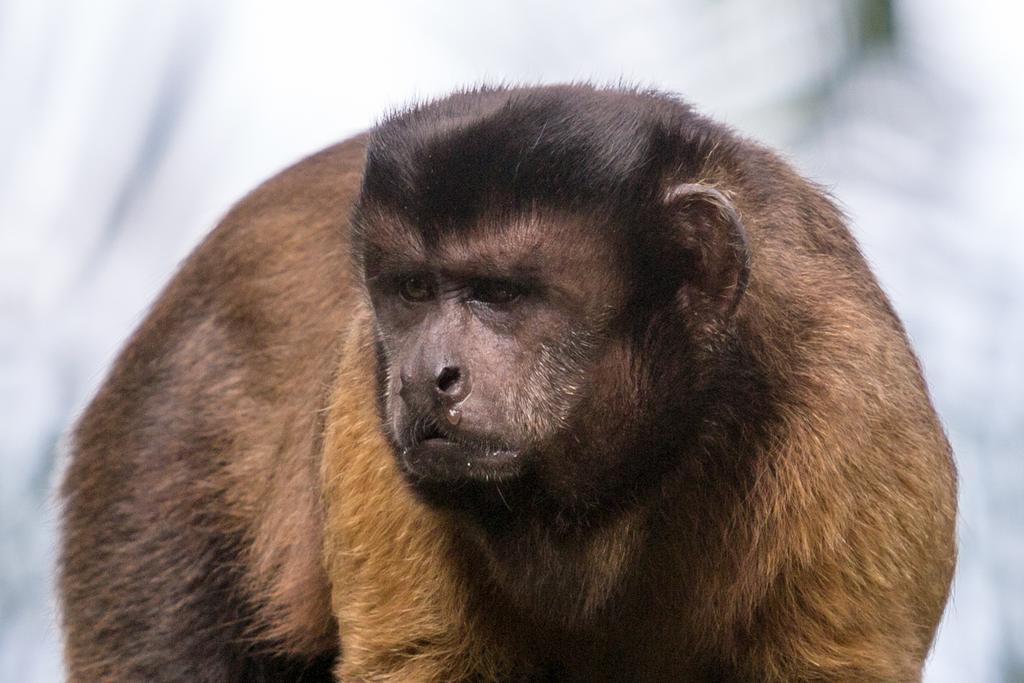How would you summarize this image in a sentence or two? In this image, we can see an ape on the blur background. 